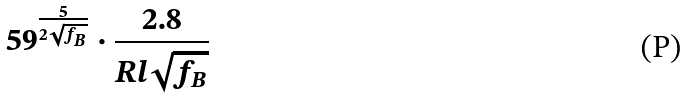<formula> <loc_0><loc_0><loc_500><loc_500>5 9 ^ { \frac { 5 } { 2 \sqrt { f _ { B } } } } \cdot \frac { 2 . 8 } { R l \sqrt { f _ { B } } }</formula> 